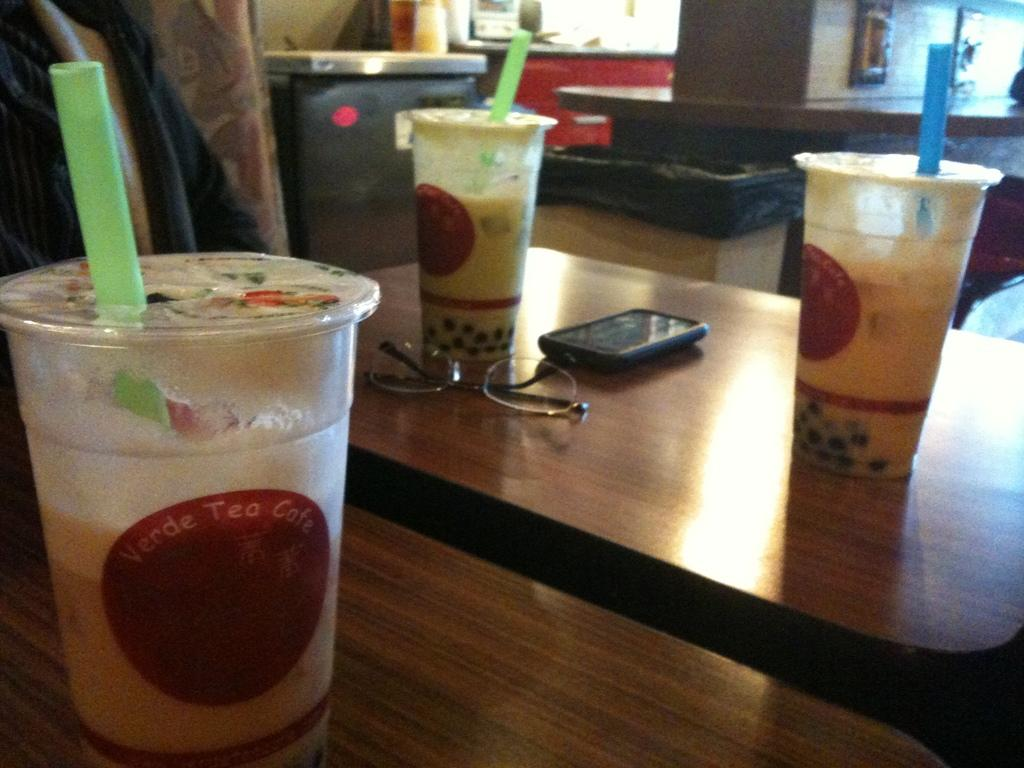<image>
Summarize the visual content of the image. Some drinks in containers which read Verde Tea Cafe 